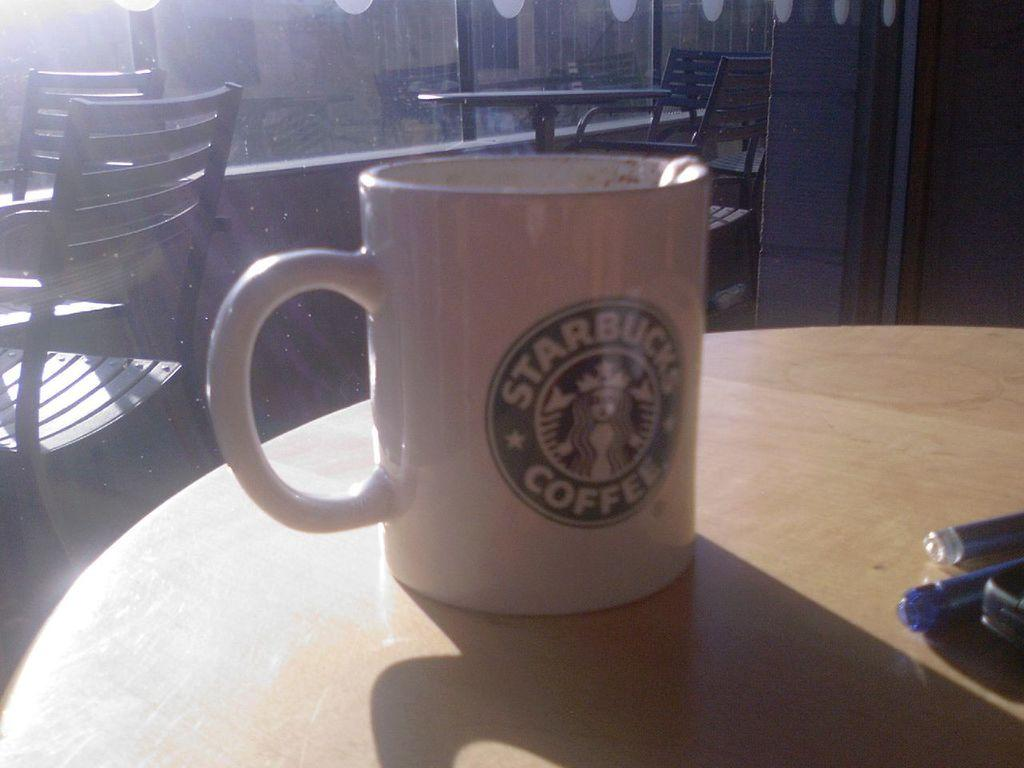<image>
Give a short and clear explanation of the subsequent image. A cup with the Starbucks Coffee logo on it. 